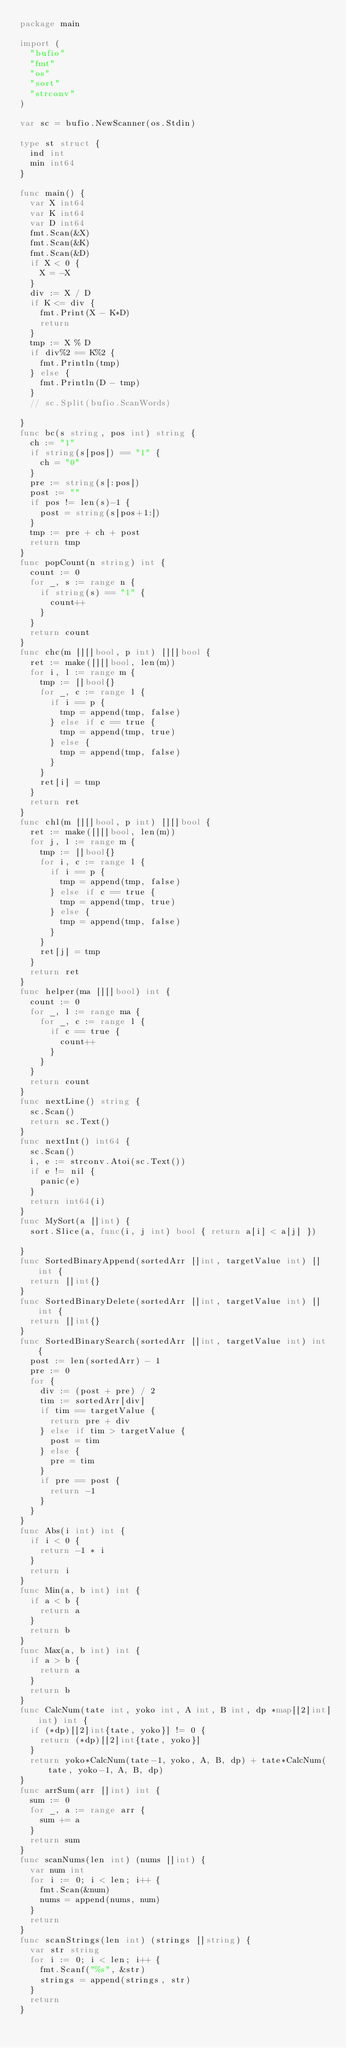<code> <loc_0><loc_0><loc_500><loc_500><_Go_>package main

import (
	"bufio"
	"fmt"
	"os"
	"sort"
	"strconv"
)

var sc = bufio.NewScanner(os.Stdin)

type st struct {
	ind int
	min int64
}

func main() {
	var X int64
	var K int64
	var D int64
	fmt.Scan(&X)
	fmt.Scan(&K)
	fmt.Scan(&D)
	if X < 0 {
		X = -X
	}
	div := X / D
	if K <= div {
		fmt.Print(X - K*D)
		return
	}
	tmp := X % D
	if div%2 == K%2 {
		fmt.Println(tmp)
	} else {
		fmt.Println(D - tmp)
	}
	// sc.Split(bufio.ScanWords)

}
func bc(s string, pos int) string {
	ch := "1"
	if string(s[pos]) == "1" {
		ch = "0"
	}
	pre := string(s[:pos])
	post := ""
	if pos != len(s)-1 {
		post = string(s[pos+1:])
	}
	tmp := pre + ch + post
	return tmp
}
func popCount(n string) int {
	count := 0
	for _, s := range n {
		if string(s) == "1" {
			count++
		}
	}
	return count
}
func chc(m [][]bool, p int) [][]bool {
	ret := make([][]bool, len(m))
	for i, l := range m {
		tmp := []bool{}
		for _, c := range l {
			if i == p {
				tmp = append(tmp, false)
			} else if c == true {
				tmp = append(tmp, true)
			} else {
				tmp = append(tmp, false)
			}
		}
		ret[i] = tmp
	}
	return ret
}
func chl(m [][]bool, p int) [][]bool {
	ret := make([][]bool, len(m))
	for j, l := range m {
		tmp := []bool{}
		for i, c := range l {
			if i == p {
				tmp = append(tmp, false)
			} else if c == true {
				tmp = append(tmp, true)
			} else {
				tmp = append(tmp, false)
			}
		}
		ret[j] = tmp
	}
	return ret
}
func helper(ma [][]bool) int {
	count := 0
	for _, l := range ma {
		for _, c := range l {
			if c == true {
				count++
			}
		}
	}
	return count
}
func nextLine() string {
	sc.Scan()
	return sc.Text()
}
func nextInt() int64 {
	sc.Scan()
	i, e := strconv.Atoi(sc.Text())
	if e != nil {
		panic(e)
	}
	return int64(i)
}
func MySort(a []int) {
	sort.Slice(a, func(i, j int) bool { return a[i] < a[j] })

}
func SortedBinaryAppend(sortedArr []int, targetValue int) []int {
	return []int{}
}
func SortedBinaryDelete(sortedArr []int, targetValue int) []int {
	return []int{}
}
func SortedBinarySearch(sortedArr []int, targetValue int) int {
	post := len(sortedArr) - 1
	pre := 0
	for {
		div := (post + pre) / 2
		tim := sortedArr[div]
		if tim == targetValue {
			return pre + div
		} else if tim > targetValue {
			post = tim
		} else {
			pre = tim
		}
		if pre == post {
			return -1
		}
	}
}
func Abs(i int) int {
	if i < 0 {
		return -1 * i
	}
	return i
}
func Min(a, b int) int {
	if a < b {
		return a
	}
	return b
}
func Max(a, b int) int {
	if a > b {
		return a
	}
	return b
}
func CalcNum(tate int, yoko int, A int, B int, dp *map[[2]int]int) int {
	if (*dp)[[2]int{tate, yoko}] != 0 {
		return (*dp)[[2]int{tate, yoko}]
	}
	return yoko*CalcNum(tate-1, yoko, A, B, dp) + tate*CalcNum(tate, yoko-1, A, B, dp)
}
func arrSum(arr []int) int {
	sum := 0
	for _, a := range arr {
		sum += a
	}
	return sum
}
func scanNums(len int) (nums []int) {
	var num int
	for i := 0; i < len; i++ {
		fmt.Scan(&num)
		nums = append(nums, num)
	}
	return
}
func scanStrings(len int) (strings []string) {
	var str string
	for i := 0; i < len; i++ {
		fmt.Scanf("%s", &str)
		strings = append(strings, str)
	}
	return
}
</code> 